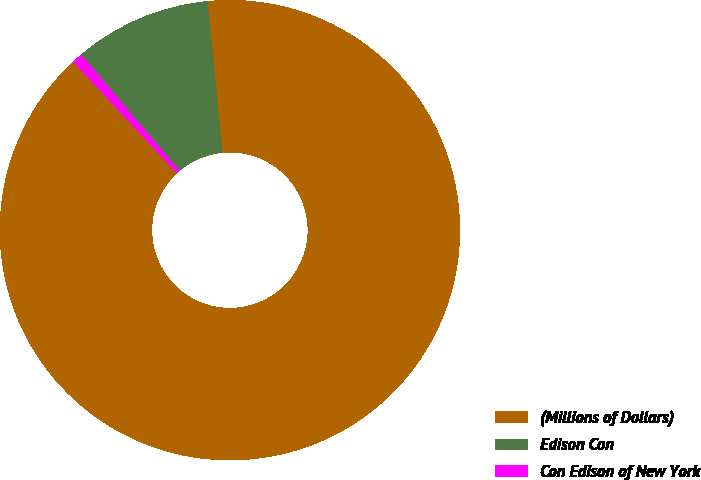<chart> <loc_0><loc_0><loc_500><loc_500><pie_chart><fcel>(Millions of Dollars)<fcel>Edison Con<fcel>Con Edison of New York<nl><fcel>89.6%<fcel>9.64%<fcel>0.76%<nl></chart> 